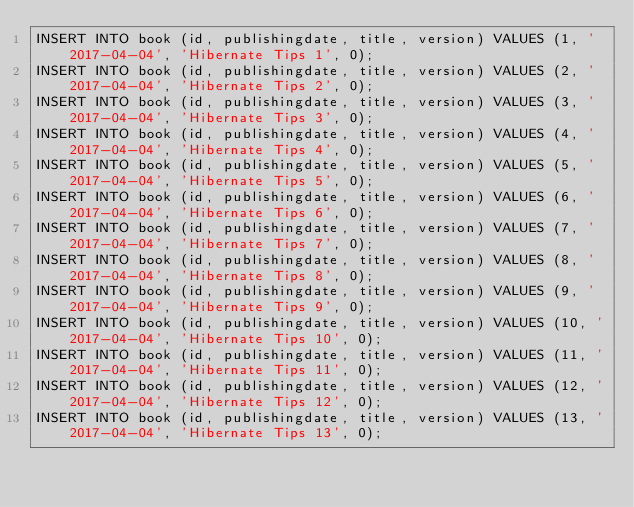<code> <loc_0><loc_0><loc_500><loc_500><_SQL_>INSERT INTO book (id, publishingdate, title, version) VALUES (1, '2017-04-04', 'Hibernate Tips 1', 0);
INSERT INTO book (id, publishingdate, title, version) VALUES (2, '2017-04-04', 'Hibernate Tips 2', 0);
INSERT INTO book (id, publishingdate, title, version) VALUES (3, '2017-04-04', 'Hibernate Tips 3', 0);
INSERT INTO book (id, publishingdate, title, version) VALUES (4, '2017-04-04', 'Hibernate Tips 4', 0);
INSERT INTO book (id, publishingdate, title, version) VALUES (5, '2017-04-04', 'Hibernate Tips 5', 0);
INSERT INTO book (id, publishingdate, title, version) VALUES (6, '2017-04-04', 'Hibernate Tips 6', 0);
INSERT INTO book (id, publishingdate, title, version) VALUES (7, '2017-04-04', 'Hibernate Tips 7', 0);
INSERT INTO book (id, publishingdate, title, version) VALUES (8, '2017-04-04', 'Hibernate Tips 8', 0);
INSERT INTO book (id, publishingdate, title, version) VALUES (9, '2017-04-04', 'Hibernate Tips 9', 0);
INSERT INTO book (id, publishingdate, title, version) VALUES (10, '2017-04-04', 'Hibernate Tips 10', 0);
INSERT INTO book (id, publishingdate, title, version) VALUES (11, '2017-04-04', 'Hibernate Tips 11', 0);
INSERT INTO book (id, publishingdate, title, version) VALUES (12, '2017-04-04', 'Hibernate Tips 12', 0);
INSERT INTO book (id, publishingdate, title, version) VALUES (13, '2017-04-04', 'Hibernate Tips 13', 0);</code> 